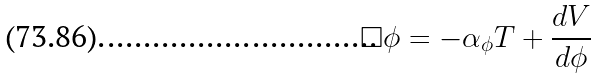<formula> <loc_0><loc_0><loc_500><loc_500>\Box \phi = - \alpha _ { \phi } T + \frac { d V } { d \phi }</formula> 